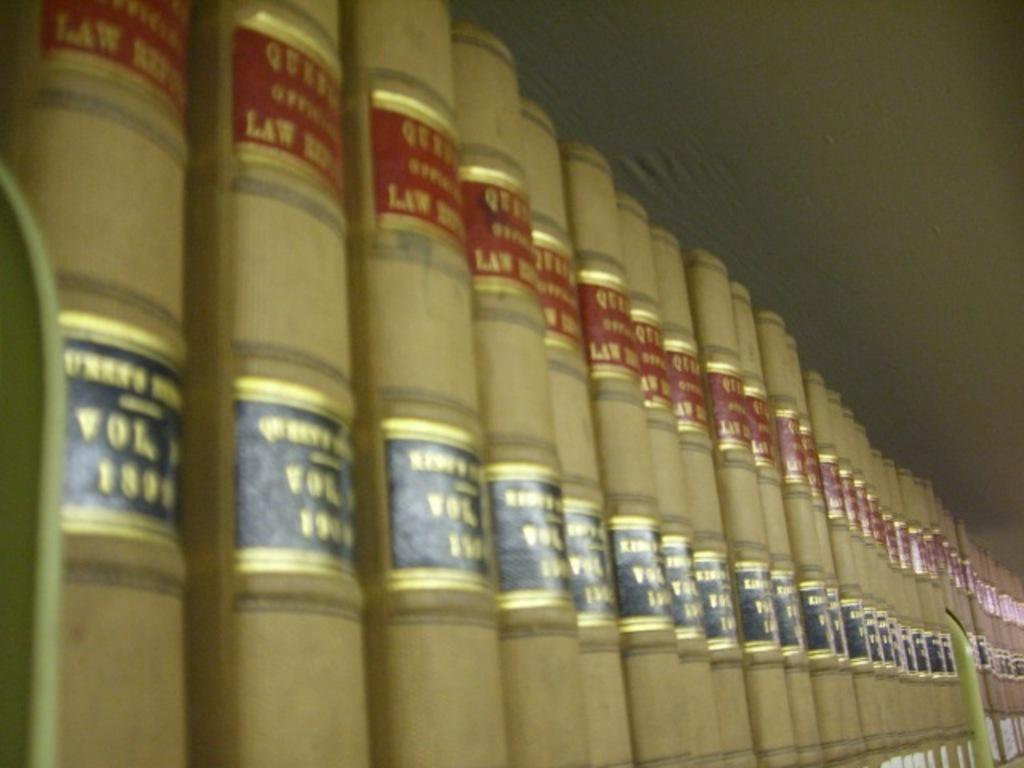<image>
Present a compact description of the photo's key features. Tan with red and black Law books are lined up on a shelf. 